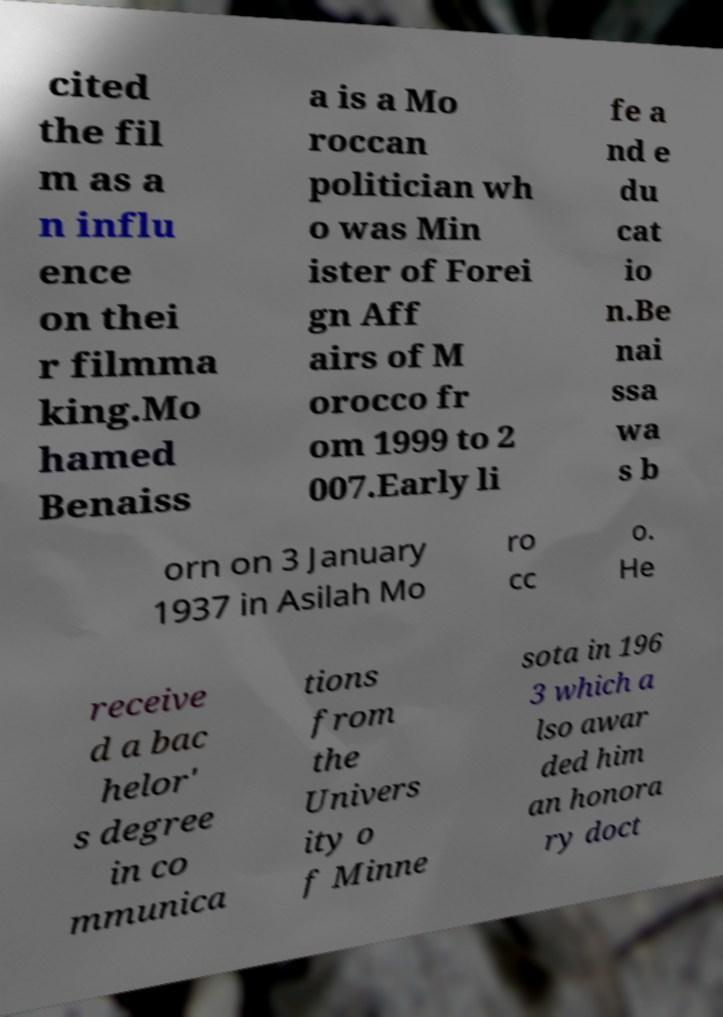There's text embedded in this image that I need extracted. Can you transcribe it verbatim? cited the fil m as a n influ ence on thei r filmma king.Mo hamed Benaiss a is a Mo roccan politician wh o was Min ister of Forei gn Aff airs of M orocco fr om 1999 to 2 007.Early li fe a nd e du cat io n.Be nai ssa wa s b orn on 3 January 1937 in Asilah Mo ro cc o. He receive d a bac helor' s degree in co mmunica tions from the Univers ity o f Minne sota in 196 3 which a lso awar ded him an honora ry doct 